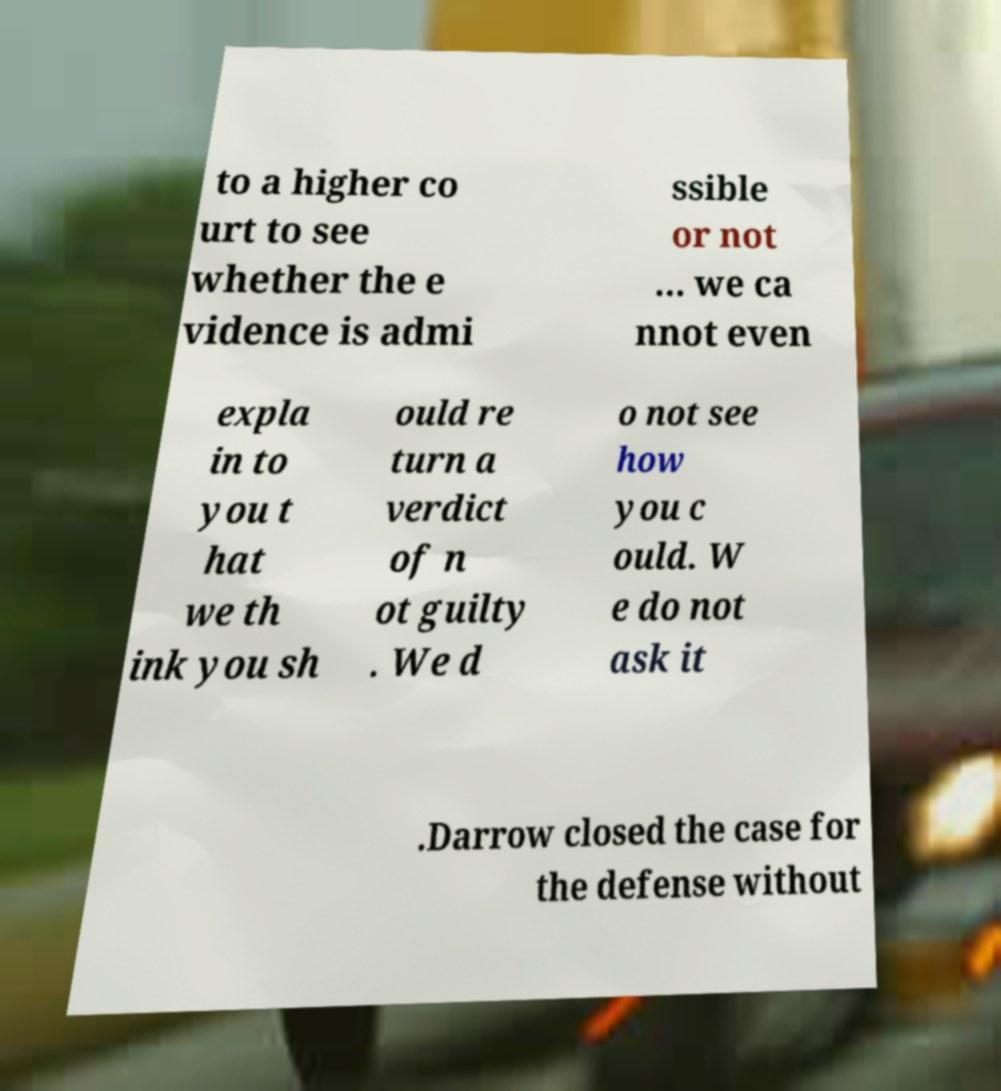Could you extract and type out the text from this image? to a higher co urt to see whether the e vidence is admi ssible or not ... we ca nnot even expla in to you t hat we th ink you sh ould re turn a verdict of n ot guilty . We d o not see how you c ould. W e do not ask it .Darrow closed the case for the defense without 